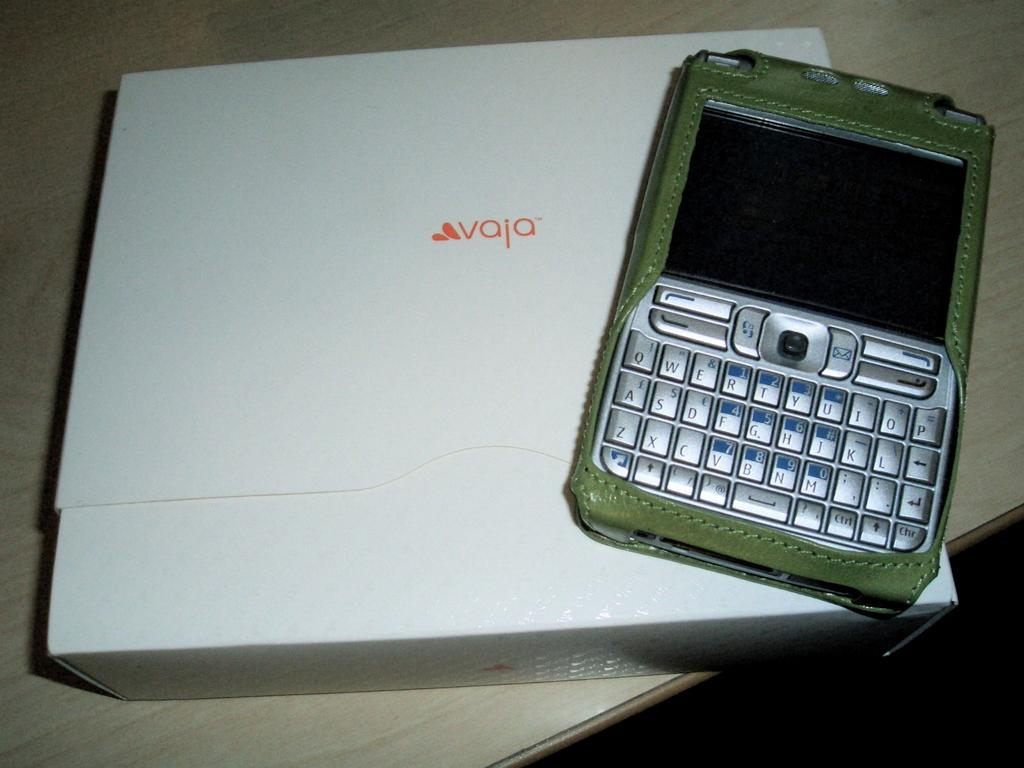<image>
Render a clear and concise summary of the photo. a smart phone from vaja with a qwerty keyboard 